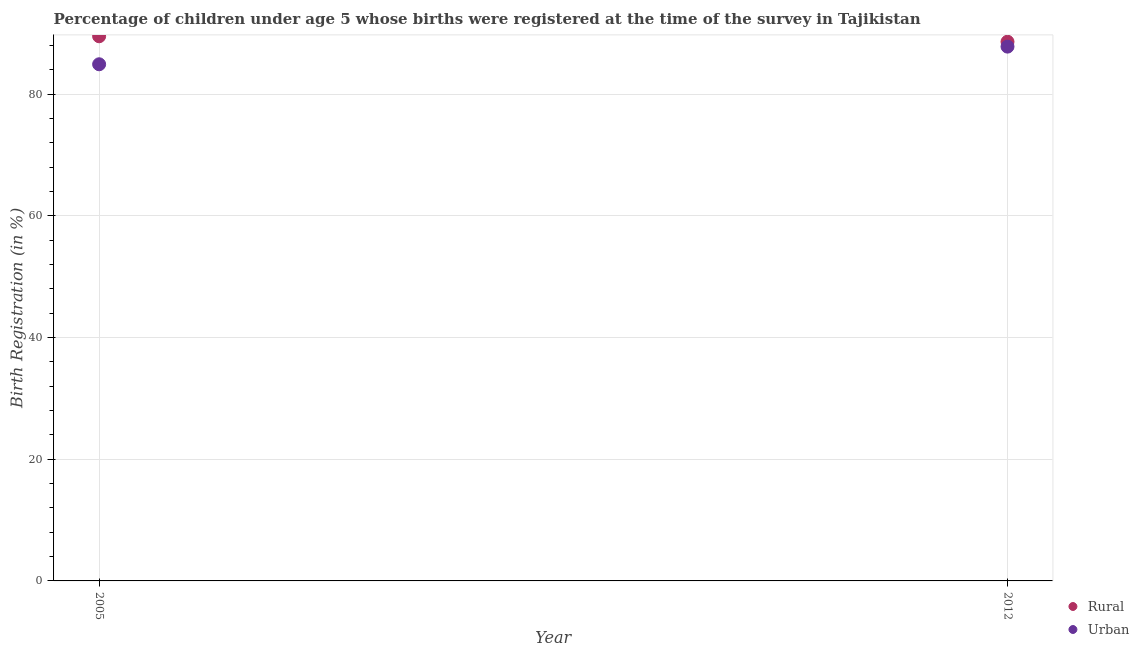How many different coloured dotlines are there?
Provide a short and direct response. 2. What is the urban birth registration in 2012?
Your response must be concise. 87.8. Across all years, what is the maximum rural birth registration?
Make the answer very short. 89.5. Across all years, what is the minimum urban birth registration?
Offer a very short reply. 84.9. In which year was the urban birth registration minimum?
Ensure brevity in your answer.  2005. What is the total rural birth registration in the graph?
Your answer should be compact. 178.1. What is the difference between the urban birth registration in 2005 and that in 2012?
Your answer should be compact. -2.9. What is the difference between the rural birth registration in 2012 and the urban birth registration in 2005?
Give a very brief answer. 3.7. What is the average urban birth registration per year?
Make the answer very short. 86.35. In the year 2012, what is the difference between the urban birth registration and rural birth registration?
Keep it short and to the point. -0.8. In how many years, is the urban birth registration greater than 36 %?
Your answer should be very brief. 2. What is the ratio of the urban birth registration in 2005 to that in 2012?
Offer a very short reply. 0.97. Is the rural birth registration in 2005 less than that in 2012?
Your answer should be very brief. No. Does the urban birth registration monotonically increase over the years?
Your answer should be compact. Yes. Is the urban birth registration strictly less than the rural birth registration over the years?
Your response must be concise. Yes. Does the graph contain any zero values?
Your answer should be very brief. No. Where does the legend appear in the graph?
Keep it short and to the point. Bottom right. What is the title of the graph?
Offer a terse response. Percentage of children under age 5 whose births were registered at the time of the survey in Tajikistan. Does "From World Bank" appear as one of the legend labels in the graph?
Offer a terse response. No. What is the label or title of the X-axis?
Your response must be concise. Year. What is the label or title of the Y-axis?
Your answer should be very brief. Birth Registration (in %). What is the Birth Registration (in %) of Rural in 2005?
Your response must be concise. 89.5. What is the Birth Registration (in %) in Urban in 2005?
Make the answer very short. 84.9. What is the Birth Registration (in %) of Rural in 2012?
Give a very brief answer. 88.6. What is the Birth Registration (in %) of Urban in 2012?
Your answer should be very brief. 87.8. Across all years, what is the maximum Birth Registration (in %) in Rural?
Offer a very short reply. 89.5. Across all years, what is the maximum Birth Registration (in %) in Urban?
Your answer should be very brief. 87.8. Across all years, what is the minimum Birth Registration (in %) of Rural?
Your answer should be compact. 88.6. Across all years, what is the minimum Birth Registration (in %) in Urban?
Ensure brevity in your answer.  84.9. What is the total Birth Registration (in %) in Rural in the graph?
Make the answer very short. 178.1. What is the total Birth Registration (in %) of Urban in the graph?
Offer a very short reply. 172.7. What is the difference between the Birth Registration (in %) of Rural in 2005 and that in 2012?
Offer a terse response. 0.9. What is the average Birth Registration (in %) in Rural per year?
Ensure brevity in your answer.  89.05. What is the average Birth Registration (in %) of Urban per year?
Ensure brevity in your answer.  86.35. In the year 2005, what is the difference between the Birth Registration (in %) of Rural and Birth Registration (in %) of Urban?
Provide a short and direct response. 4.6. What is the ratio of the Birth Registration (in %) in Rural in 2005 to that in 2012?
Ensure brevity in your answer.  1.01. What is the difference between the highest and the second highest Birth Registration (in %) in Rural?
Keep it short and to the point. 0.9. What is the difference between the highest and the second highest Birth Registration (in %) of Urban?
Provide a short and direct response. 2.9. 